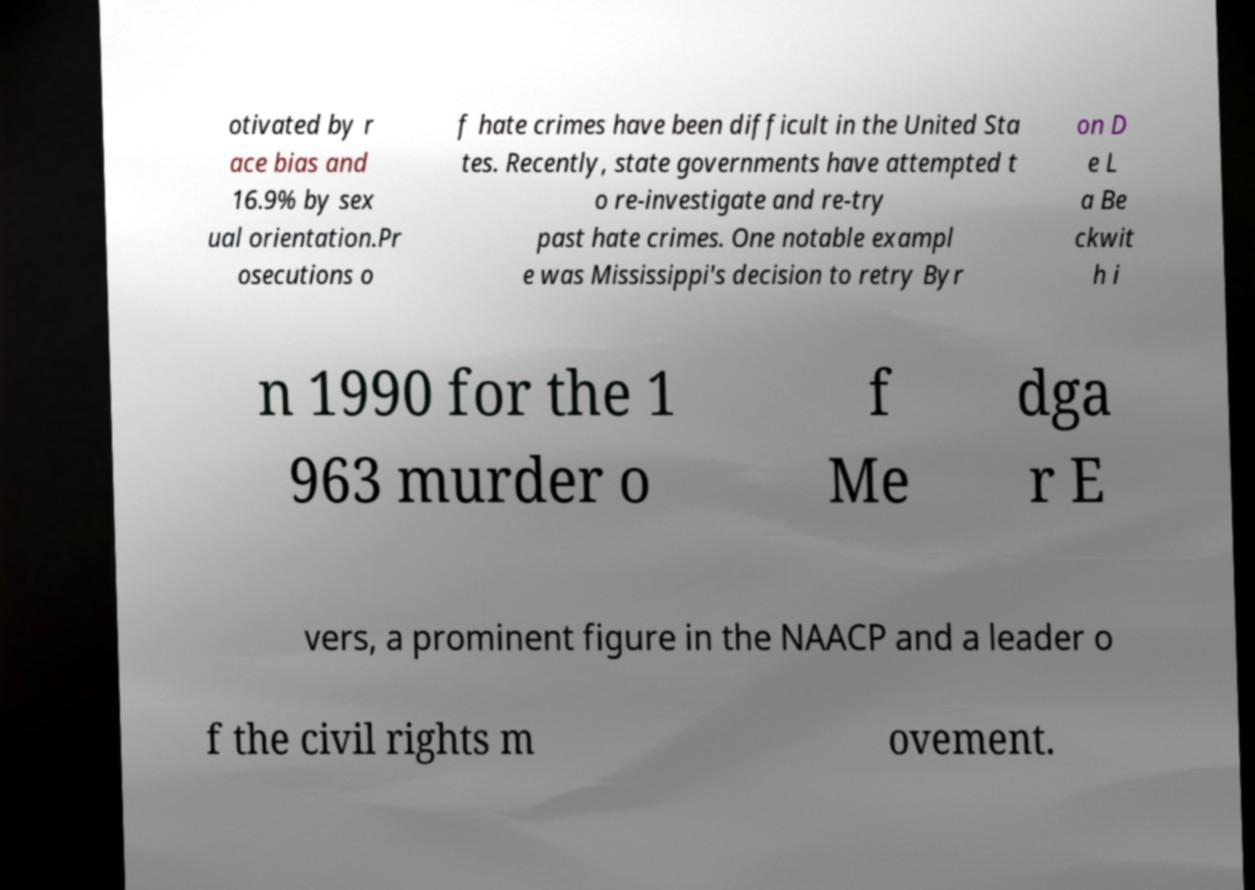Please read and relay the text visible in this image. What does it say? otivated by r ace bias and 16.9% by sex ual orientation.Pr osecutions o f hate crimes have been difficult in the United Sta tes. Recently, state governments have attempted t o re-investigate and re-try past hate crimes. One notable exampl e was Mississippi's decision to retry Byr on D e L a Be ckwit h i n 1990 for the 1 963 murder o f Me dga r E vers, a prominent figure in the NAACP and a leader o f the civil rights m ovement. 